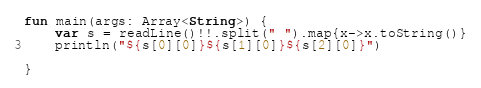<code> <loc_0><loc_0><loc_500><loc_500><_Kotlin_>fun main(args: Array<String>) {
    var s = readLine()!!.split(" ").map{x->x.toString()}
    println("${s[0][0]}${s[1][0]}${s[2][0]}")
    
}
</code> 